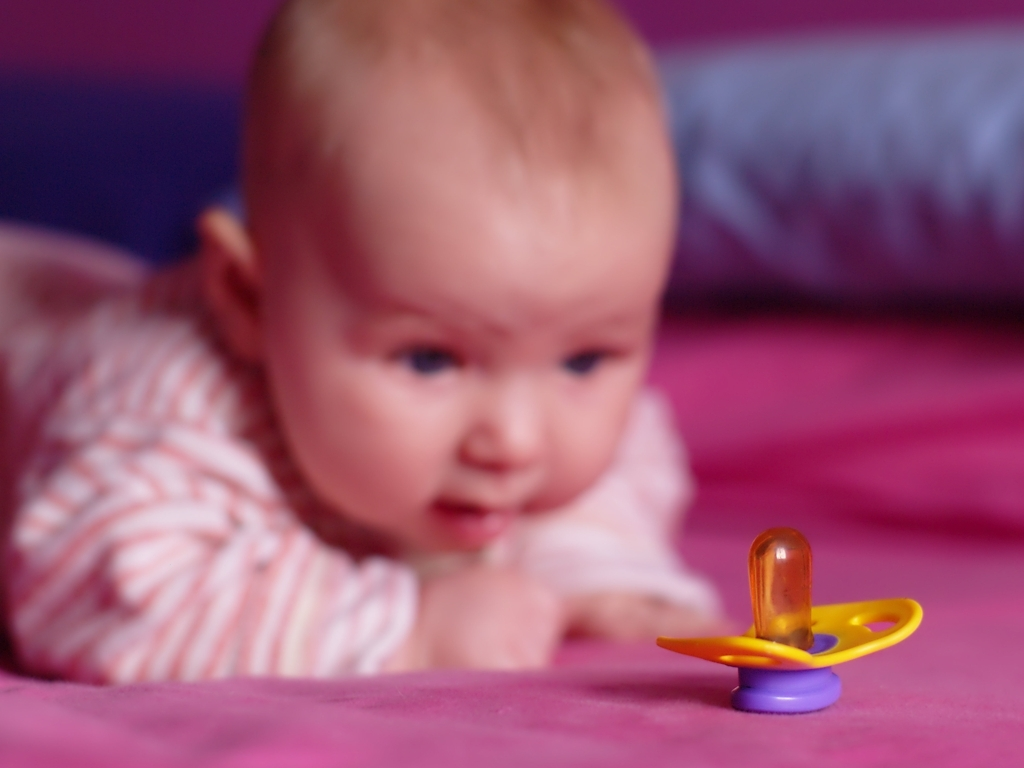How might the composition of this photo be improved? To improve the composition, the photographer could consider the 'rule of thirds' by adjusting the camera angle or the infant's position to create a more visually engaging shot. Focusing sharply on the infant's face can help draw the viewer's attention to the subject directly. Moreover, including the entire pacifier in the frame or using a different angle that features the infant interacting with the pacifier could add context and tell a more compelling story about the moment being captured. 